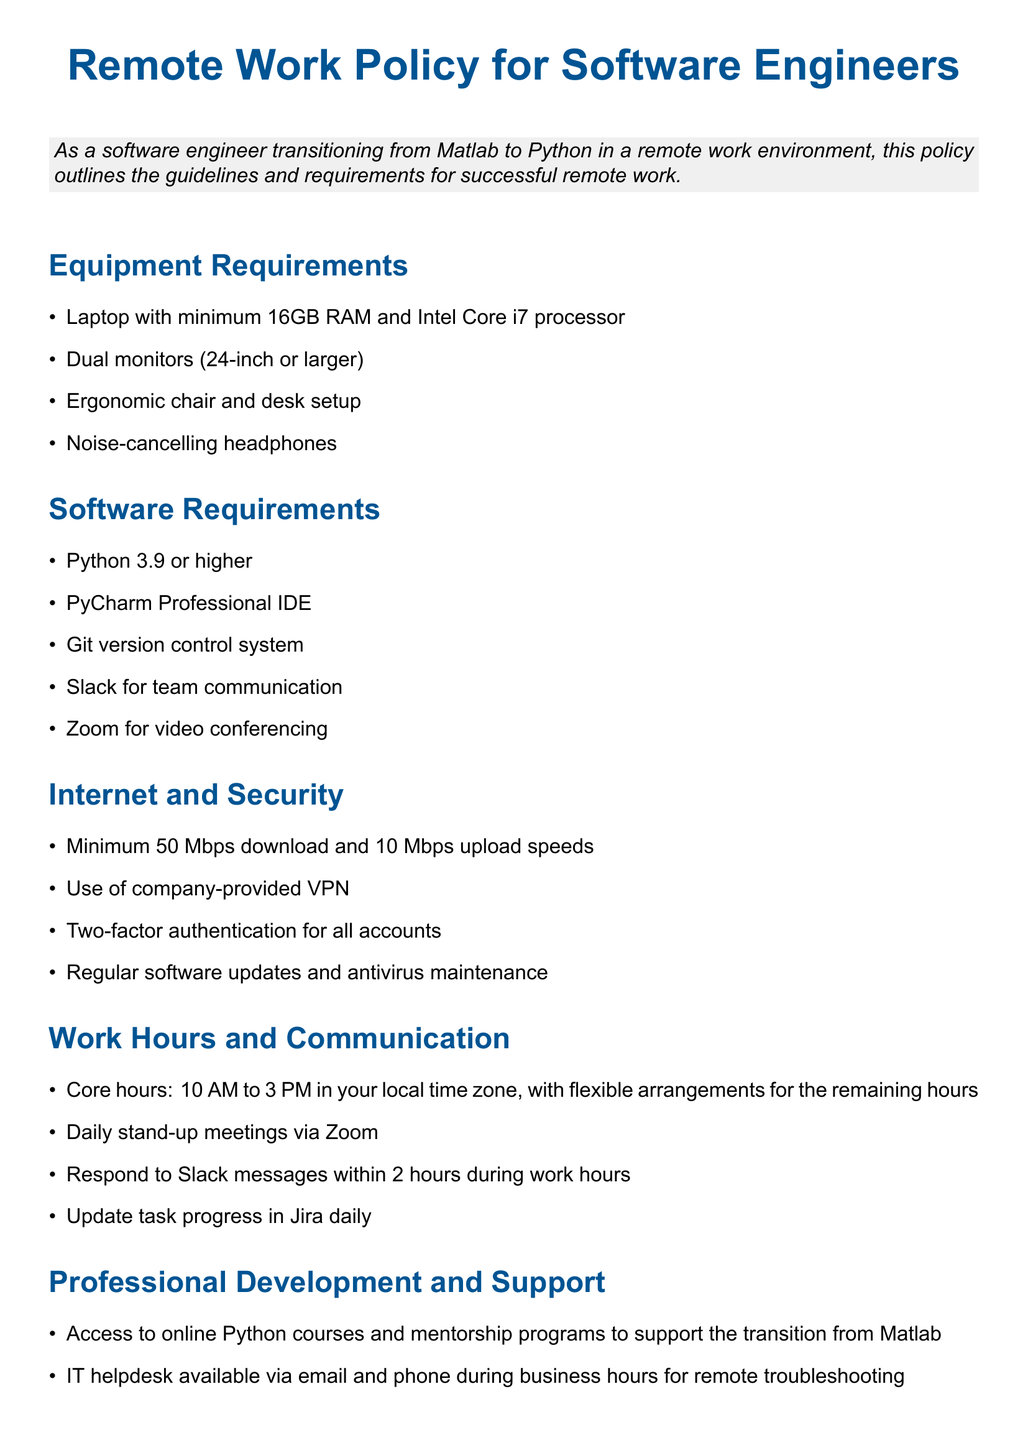What are the minimum laptop specifications? The laptop specifications are mentioned in the Equipment Requirements section, which states the minimum required specs.
Answer: 16GB RAM and Intel Core i7 processor What software is required for remote work? This information is listed in the Software Requirements section that outlines the necessary software tools for work.
Answer: Python 3.9 or higher What is the minimum download speed requirement? The minimum internet download speed requirement can be found in the Internet and Security section, which outlines the necessary internet speeds.
Answer: 50 Mbps What time are the core work hours? The core work hours are specified in the Work Hours and Communication section, detailing when employees must be available.
Answer: 10 AM to 3 PM What kind of development support is mentioned in the document? The Professional Development and Support section lists types of support available for employees, which focuses on improving skills.
Answer: Online Python courses and mentorship programs What communication tool is used for video conferencing? The required tool for video conferencing is stated in the Software Requirements section of the document.
Answer: Zoom What is the requirement for responding to Slack messages? The document outlines communication expectations in the Work Hours and Communication section, specifying response times for messages.
Answer: Within 2 hours How often should task progress be updated in Jira? This requirement can be found in the Work Hours and Communication section that discusses updates related to work tasks.
Answer: Daily 